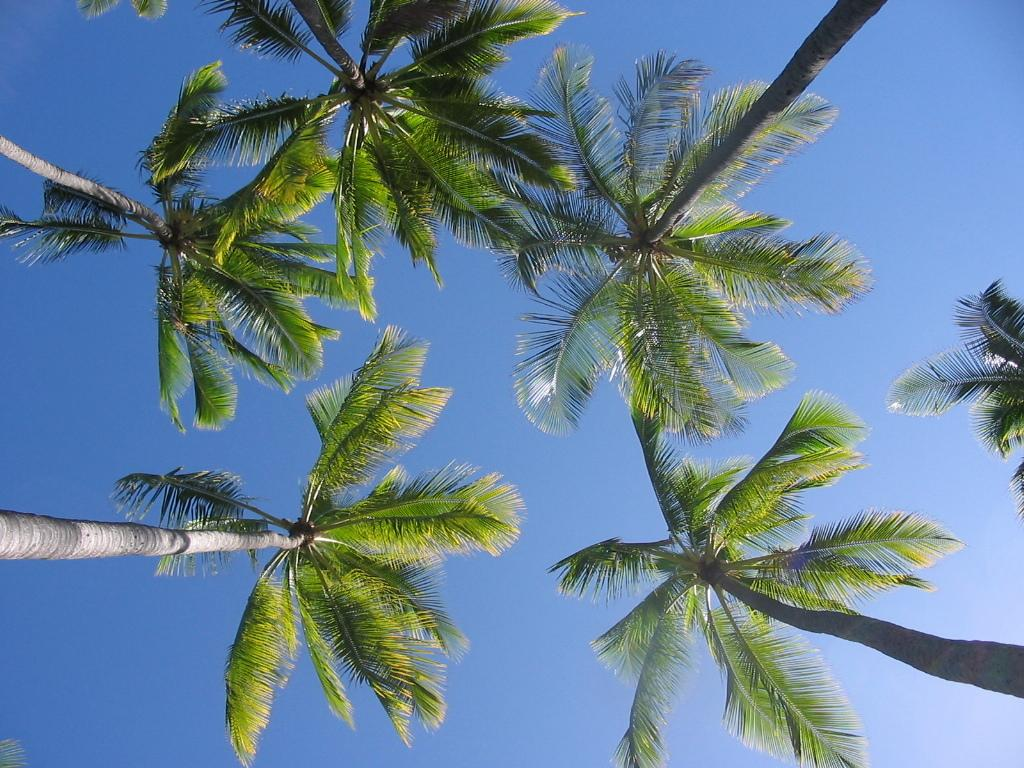What type of vegetation can be seen in the image? There are trees in the image. What part of the natural environment is visible in the image? The sky is visible in the background of the image. How many cars are parked on the bridge in the image? There is no bridge or car present in the image; it only features trees and the sky. 